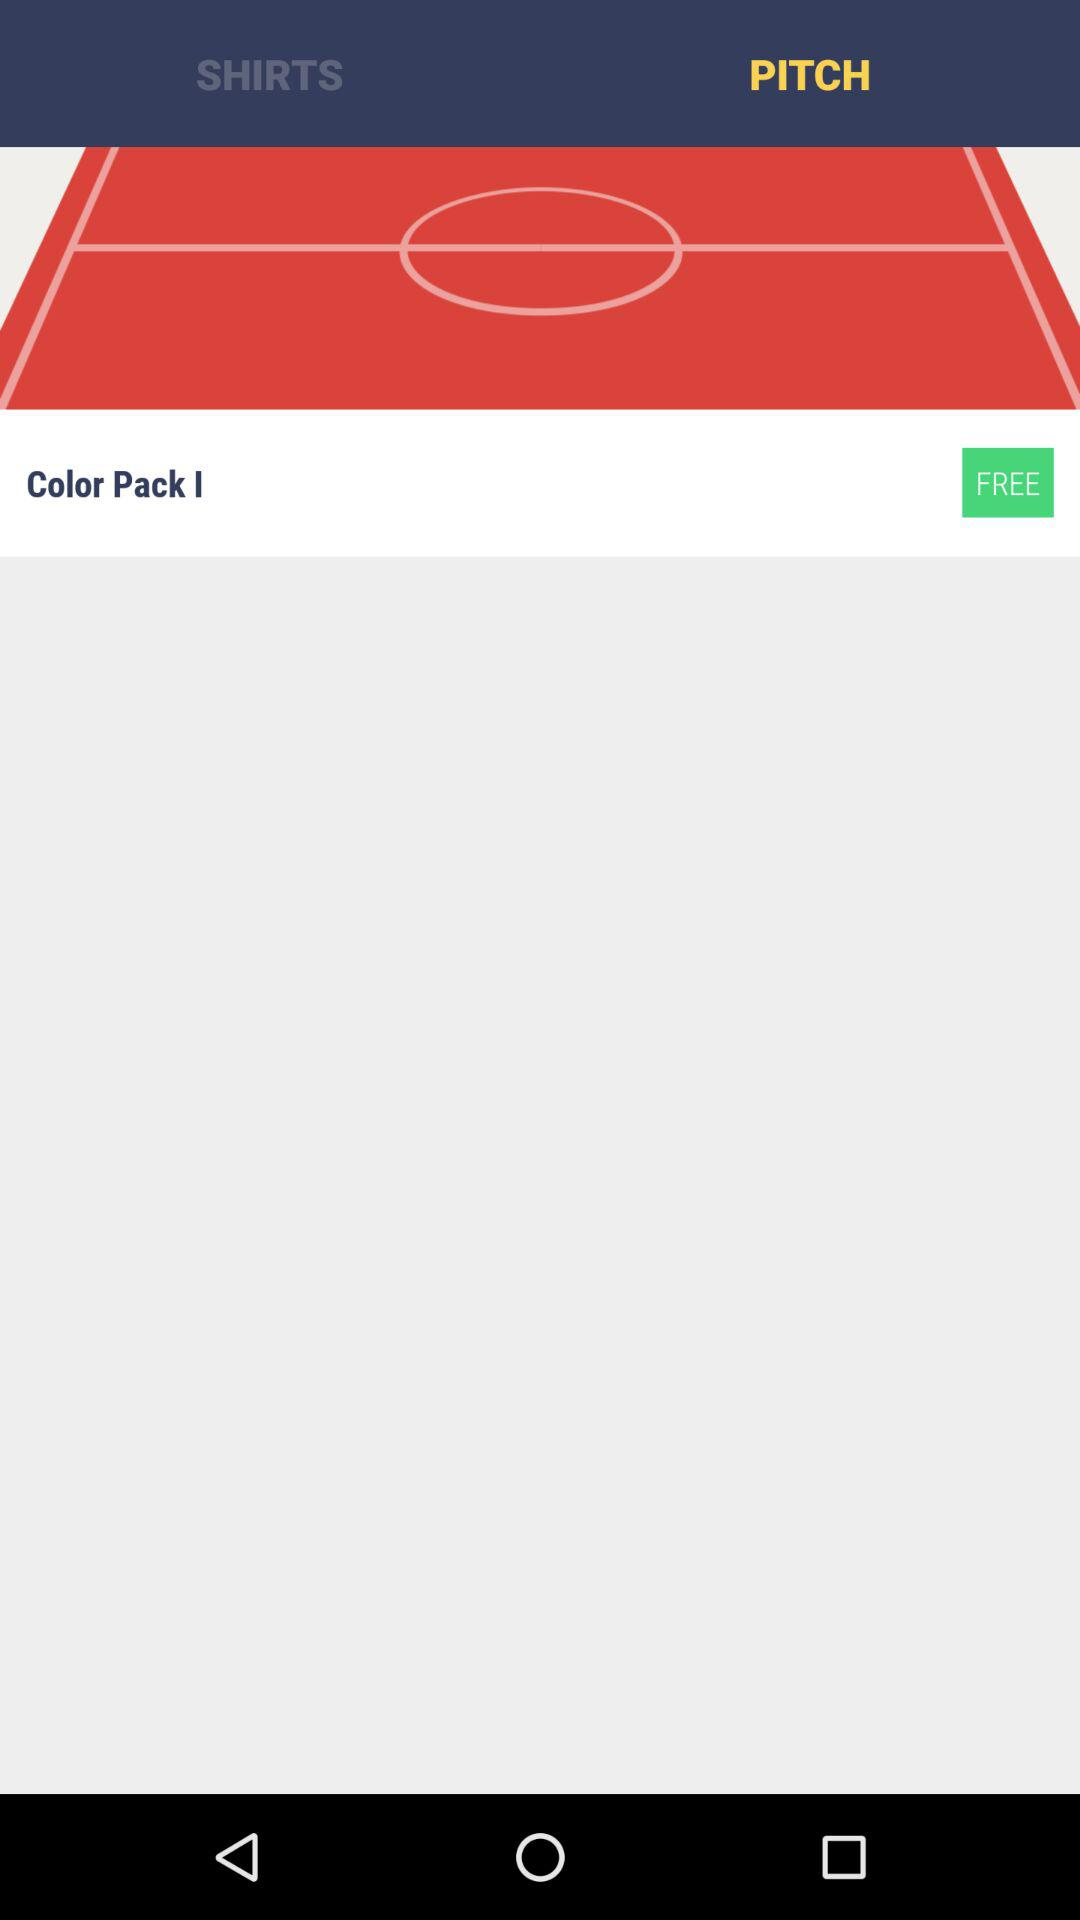What's the selected tab? The selected tab is "PITCH". 